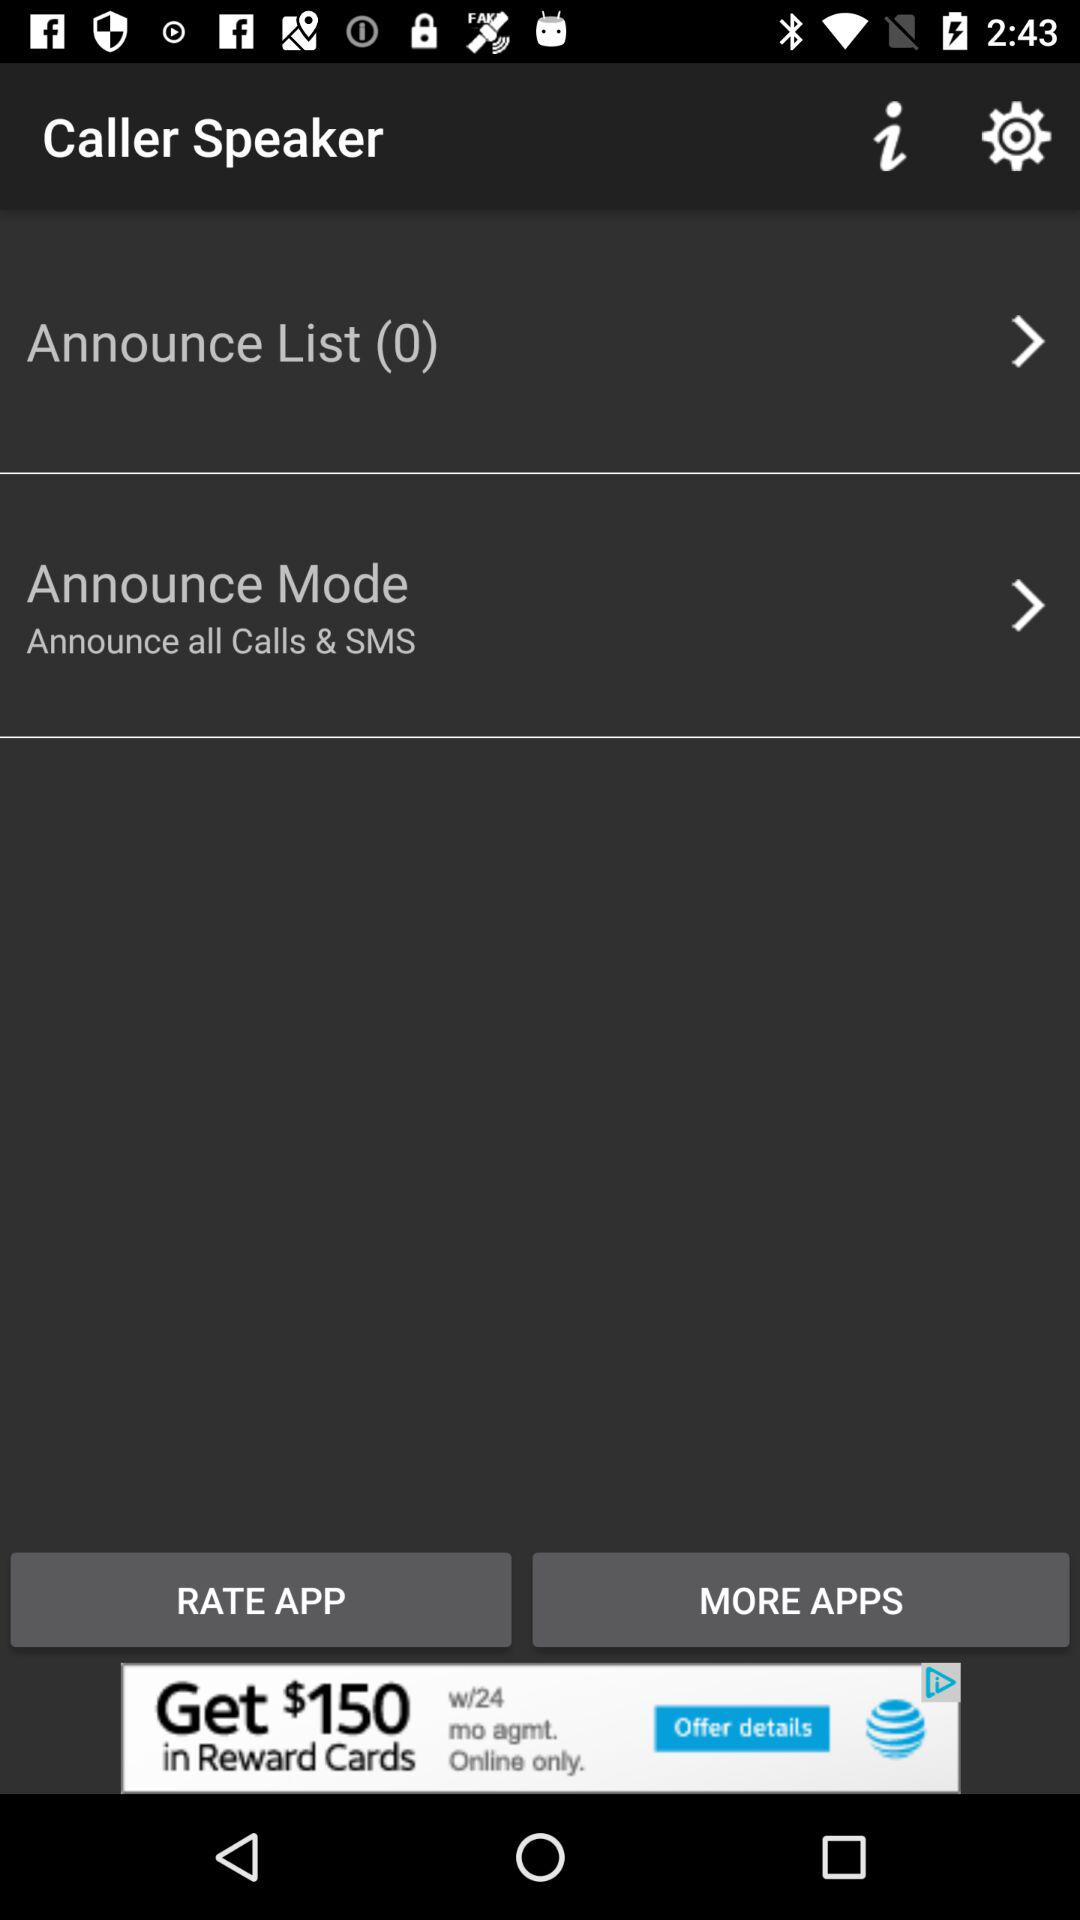What is the setting for announce mode? The setting for announce mode is "Announce all Calls & SMS". 